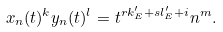<formula> <loc_0><loc_0><loc_500><loc_500>x _ { n } ( t ) ^ { k } y _ { n } ( t ) ^ { l } = t ^ { r k ^ { \prime } _ { E } + s l ^ { \prime } _ { E } + i } n ^ { m } .</formula> 